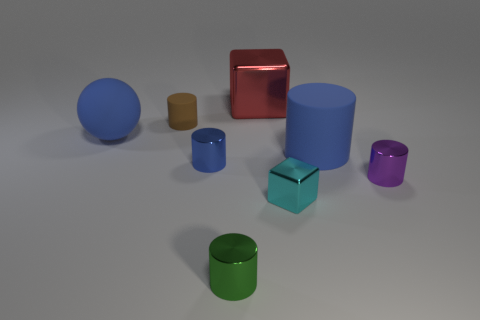Are there any other things of the same color as the large matte sphere?
Make the answer very short. Yes. Does the blue object on the right side of the green metallic cylinder have the same shape as the large blue matte thing left of the tiny green metal cylinder?
Your response must be concise. No. How many objects are tiny yellow metallic cylinders or large blue matte things left of the big cylinder?
Make the answer very short. 1. What number of other things are there of the same size as the blue metallic cylinder?
Ensure brevity in your answer.  4. Is the cube that is left of the small cube made of the same material as the tiny cylinder that is behind the blue matte cylinder?
Your response must be concise. No. How many large blue cylinders are behind the cyan thing?
Your answer should be compact. 1. What number of gray things are tiny shiny blocks or rubber spheres?
Ensure brevity in your answer.  0. What material is the blue cylinder that is the same size as the purple cylinder?
Provide a succinct answer. Metal. There is a rubber thing that is both to the right of the large matte sphere and left of the tiny blue metal thing; what is its shape?
Offer a very short reply. Cylinder. There is another rubber thing that is the same size as the cyan object; what color is it?
Offer a very short reply. Brown. 